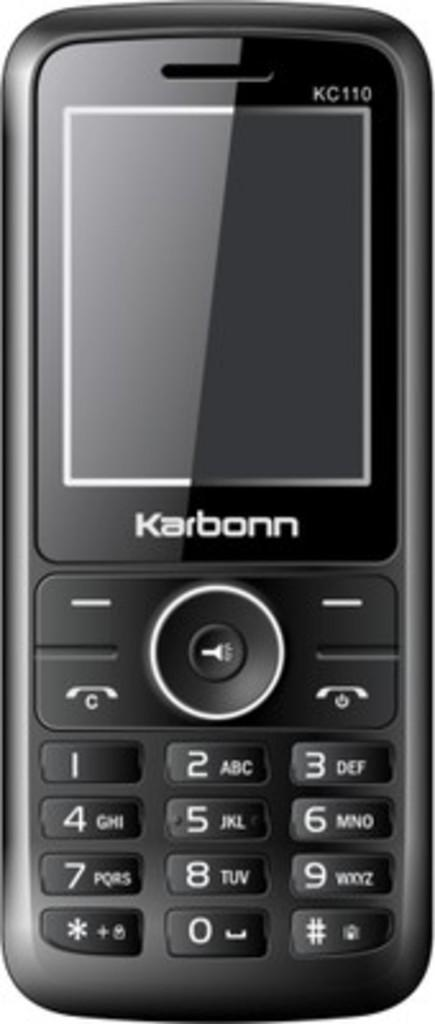<image>
Relay a brief, clear account of the picture shown. A close up of a black Karbonn KC110 phone whioch is switched off. 